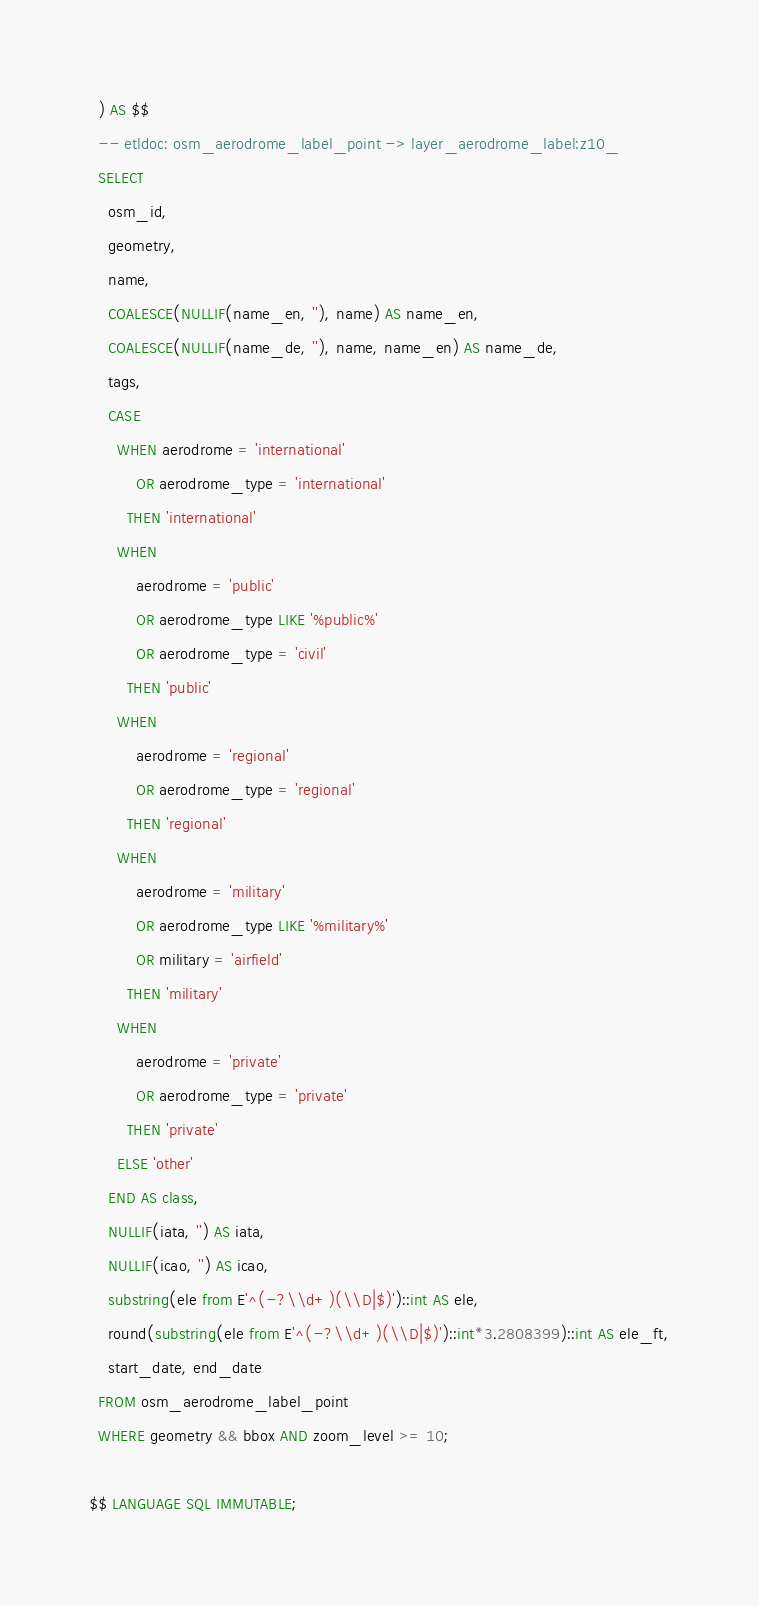<code> <loc_0><loc_0><loc_500><loc_500><_SQL_>  ) AS $$
  -- etldoc: osm_aerodrome_label_point -> layer_aerodrome_label:z10_
  SELECT
    osm_id,
    geometry,
    name,
    COALESCE(NULLIF(name_en, ''), name) AS name_en,
    COALESCE(NULLIF(name_de, ''), name, name_en) AS name_de,
    tags,
    CASE
      WHEN aerodrome = 'international'
          OR aerodrome_type = 'international'
        THEN 'international'
      WHEN
          aerodrome = 'public'
          OR aerodrome_type LIKE '%public%'
          OR aerodrome_type = 'civil'
        THEN 'public'
      WHEN
          aerodrome = 'regional'
          OR aerodrome_type = 'regional'
        THEN 'regional'
      WHEN
          aerodrome = 'military'
          OR aerodrome_type LIKE '%military%'
          OR military = 'airfield'
        THEN 'military'
      WHEN
          aerodrome = 'private'
          OR aerodrome_type = 'private'
        THEN 'private'
      ELSE 'other'
    END AS class,
    NULLIF(iata, '') AS iata,
    NULLIF(icao, '') AS icao,
    substring(ele from E'^(-?\\d+)(\\D|$)')::int AS ele,
    round(substring(ele from E'^(-?\\d+)(\\D|$)')::int*3.2808399)::int AS ele_ft,
    start_date, end_date
  FROM osm_aerodrome_label_point
  WHERE geometry && bbox AND zoom_level >= 10;

$$ LANGUAGE SQL IMMUTABLE;
</code> 